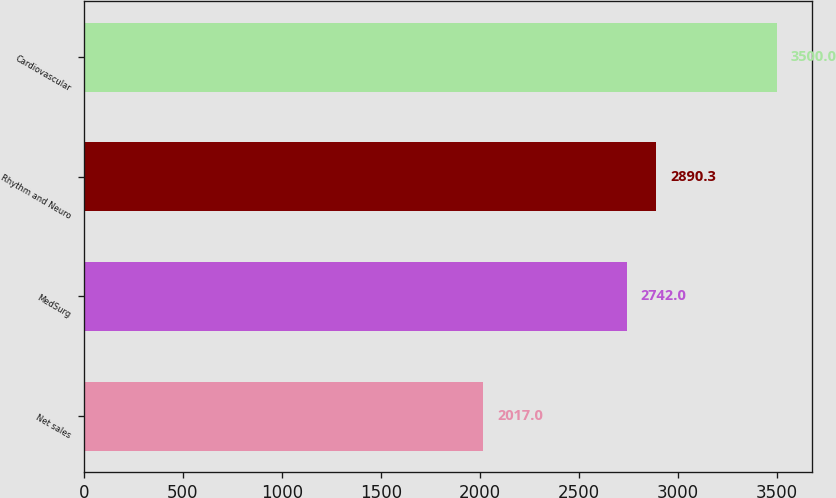<chart> <loc_0><loc_0><loc_500><loc_500><bar_chart><fcel>Net sales<fcel>MedSurg<fcel>Rhythm and Neuro<fcel>Cardiovascular<nl><fcel>2017<fcel>2742<fcel>2890.3<fcel>3500<nl></chart> 